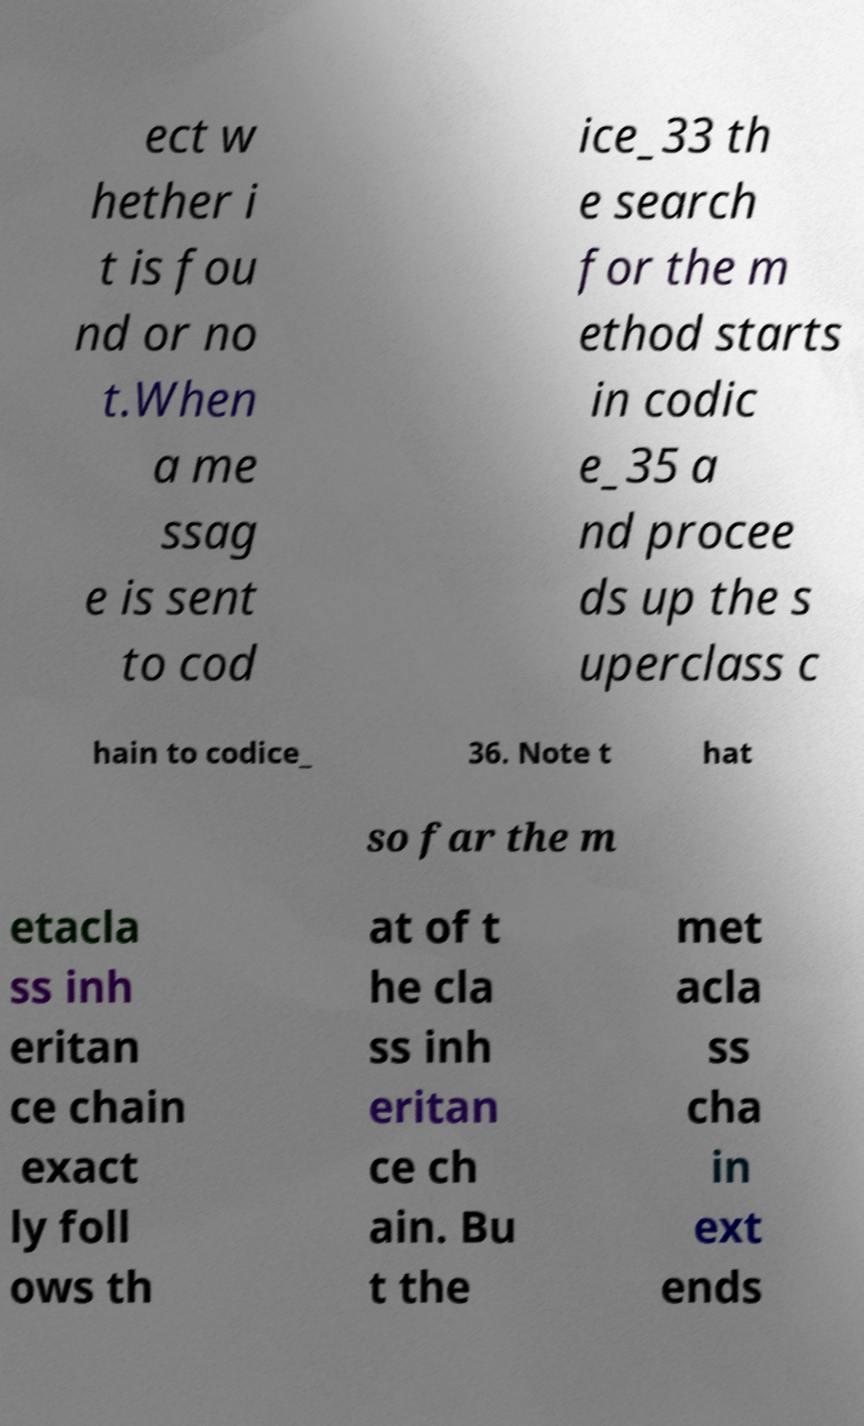Can you read and provide the text displayed in the image?This photo seems to have some interesting text. Can you extract and type it out for me? ect w hether i t is fou nd or no t.When a me ssag e is sent to cod ice_33 th e search for the m ethod starts in codic e_35 a nd procee ds up the s uperclass c hain to codice_ 36. Note t hat so far the m etacla ss inh eritan ce chain exact ly foll ows th at of t he cla ss inh eritan ce ch ain. Bu t the met acla ss cha in ext ends 